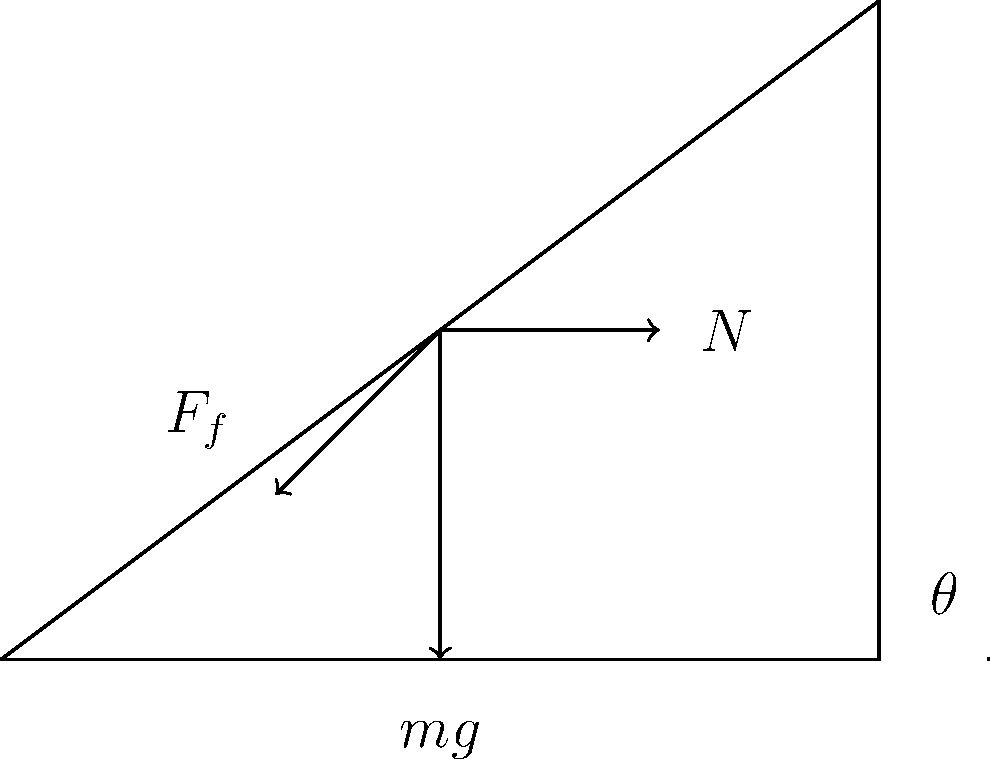A person is standing still on an inclined plane that makes an angle $\theta$ with the horizontal. Identify the forces acting on the person and explain how these forces relate to the concept of rehabilitation in your work as a probation officer. Let's break down the forces acting on the person and relate them to rehabilitation:

1. Normal Force ($N$):
   - This is the force exerted by the inclined plane perpendicular to its surface.
   - It represents the support system provided to individuals on probation.

2. Gravitational Force ($mg$):
   - This is the downward force due to gravity, always acting vertically downwards.
   - It symbolizes the challenges and negative influences that may pull an individual back into old habits.

3. Friction Force ($F_f$):
   - This force acts parallel to the inclined plane, opposing potential motion down the slope.
   - It represents the skills, support, and interventions provided during rehabilitation to prevent "backsliding."

4. Force Balance:
   - For the person to remain stationary, the sum of all forces must be zero.
   - This balance represents the goal of rehabilitation: to help individuals find stability and resist negative influences.

5. Angle $\theta$:
   - The inclination angle affects the magnitude of the forces.
   - This symbolizes how each individual's situation is unique, requiring personalized support and intervention.

In rehabilitation:
- The normal force ($N$) and friction ($F_f$) represent the support and skills provided to counteract the "downward pull" of past behaviors and negative influences (represented by $mg$).
- Just as the person must actively engage their muscles to maintain position, individuals in rehabilitation must actively participate in their own recovery and growth.
- The balance of forces demonstrates that with proper support and personal effort, individuals can overcome challenges and maintain positive change.
Answer: Normal force, gravitational force, and friction force balance to keep the person stationary, symbolizing support, challenges, and coping skills in rehabilitation. 